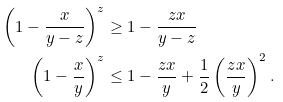<formula> <loc_0><loc_0><loc_500><loc_500>\left ( 1 - \frac { x } { y - z } \right ) ^ { z } & \geq 1 - \frac { z x } { y - z } \\ \left ( 1 - \frac { x } { y } \right ) ^ { z } & \leq 1 - \frac { z x } { y } + \frac { 1 } { 2 } \left ( \frac { z x } { y } \right ) ^ { 2 } .</formula> 